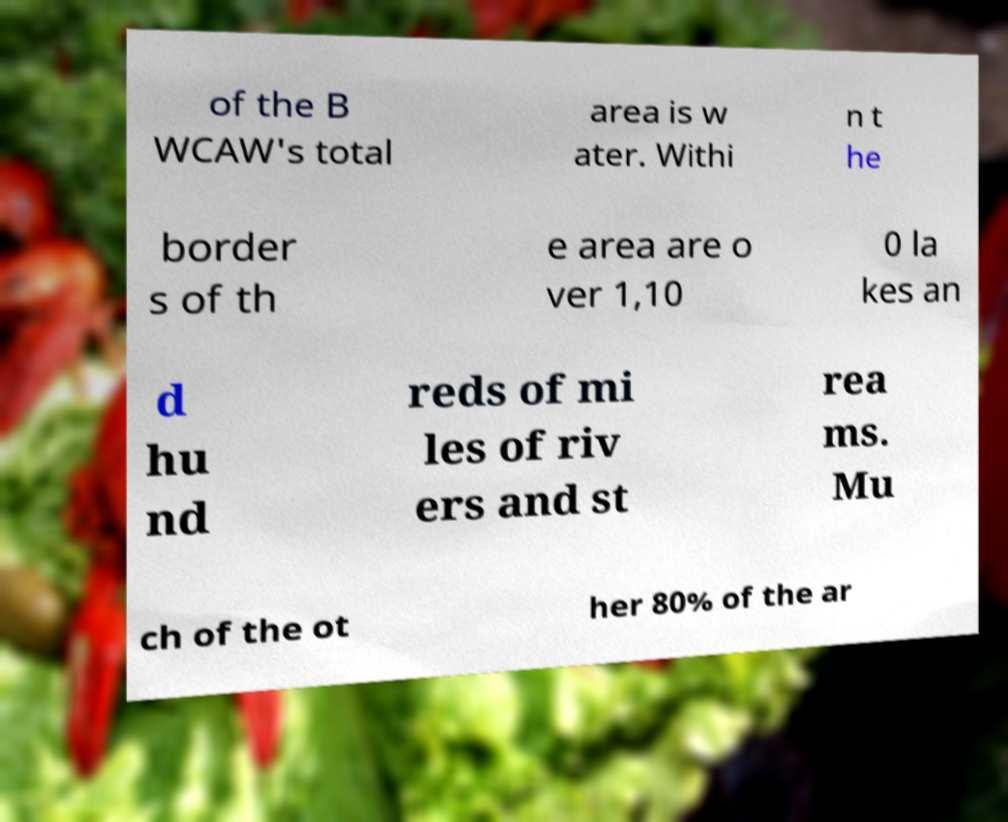What messages or text are displayed in this image? I need them in a readable, typed format. of the B WCAW's total area is w ater. Withi n t he border s of th e area are o ver 1,10 0 la kes an d hu nd reds of mi les of riv ers and st rea ms. Mu ch of the ot her 80% of the ar 